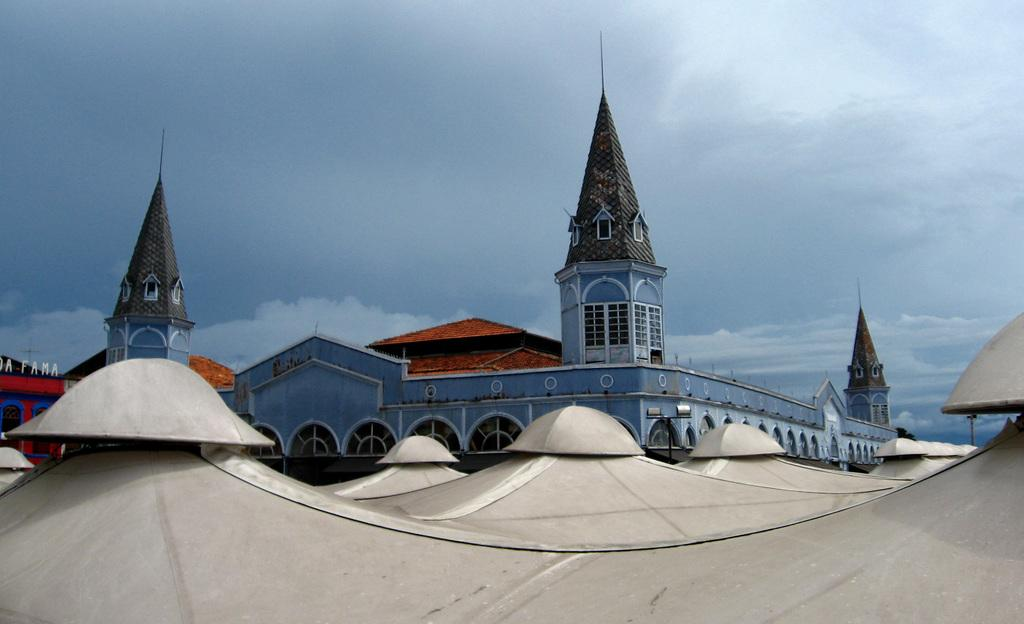What is the main structure in the image? There is a big building in the image. What is located in front of the building? There is an iron shed in front of the building. How many laborers are exchanging goods inside the iron shed? There is no information about laborers or goods exchange in the image; it only shows a big building and an iron shed. 